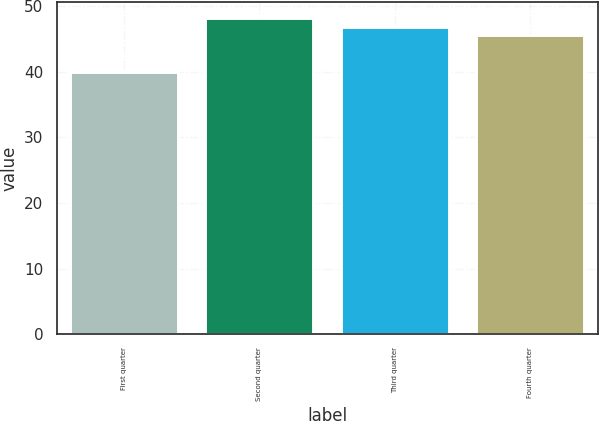Convert chart. <chart><loc_0><loc_0><loc_500><loc_500><bar_chart><fcel>First quarter<fcel>Second quarter<fcel>Third quarter<fcel>Fourth quarter<nl><fcel>39.99<fcel>48.22<fcel>46.73<fcel>45.55<nl></chart> 